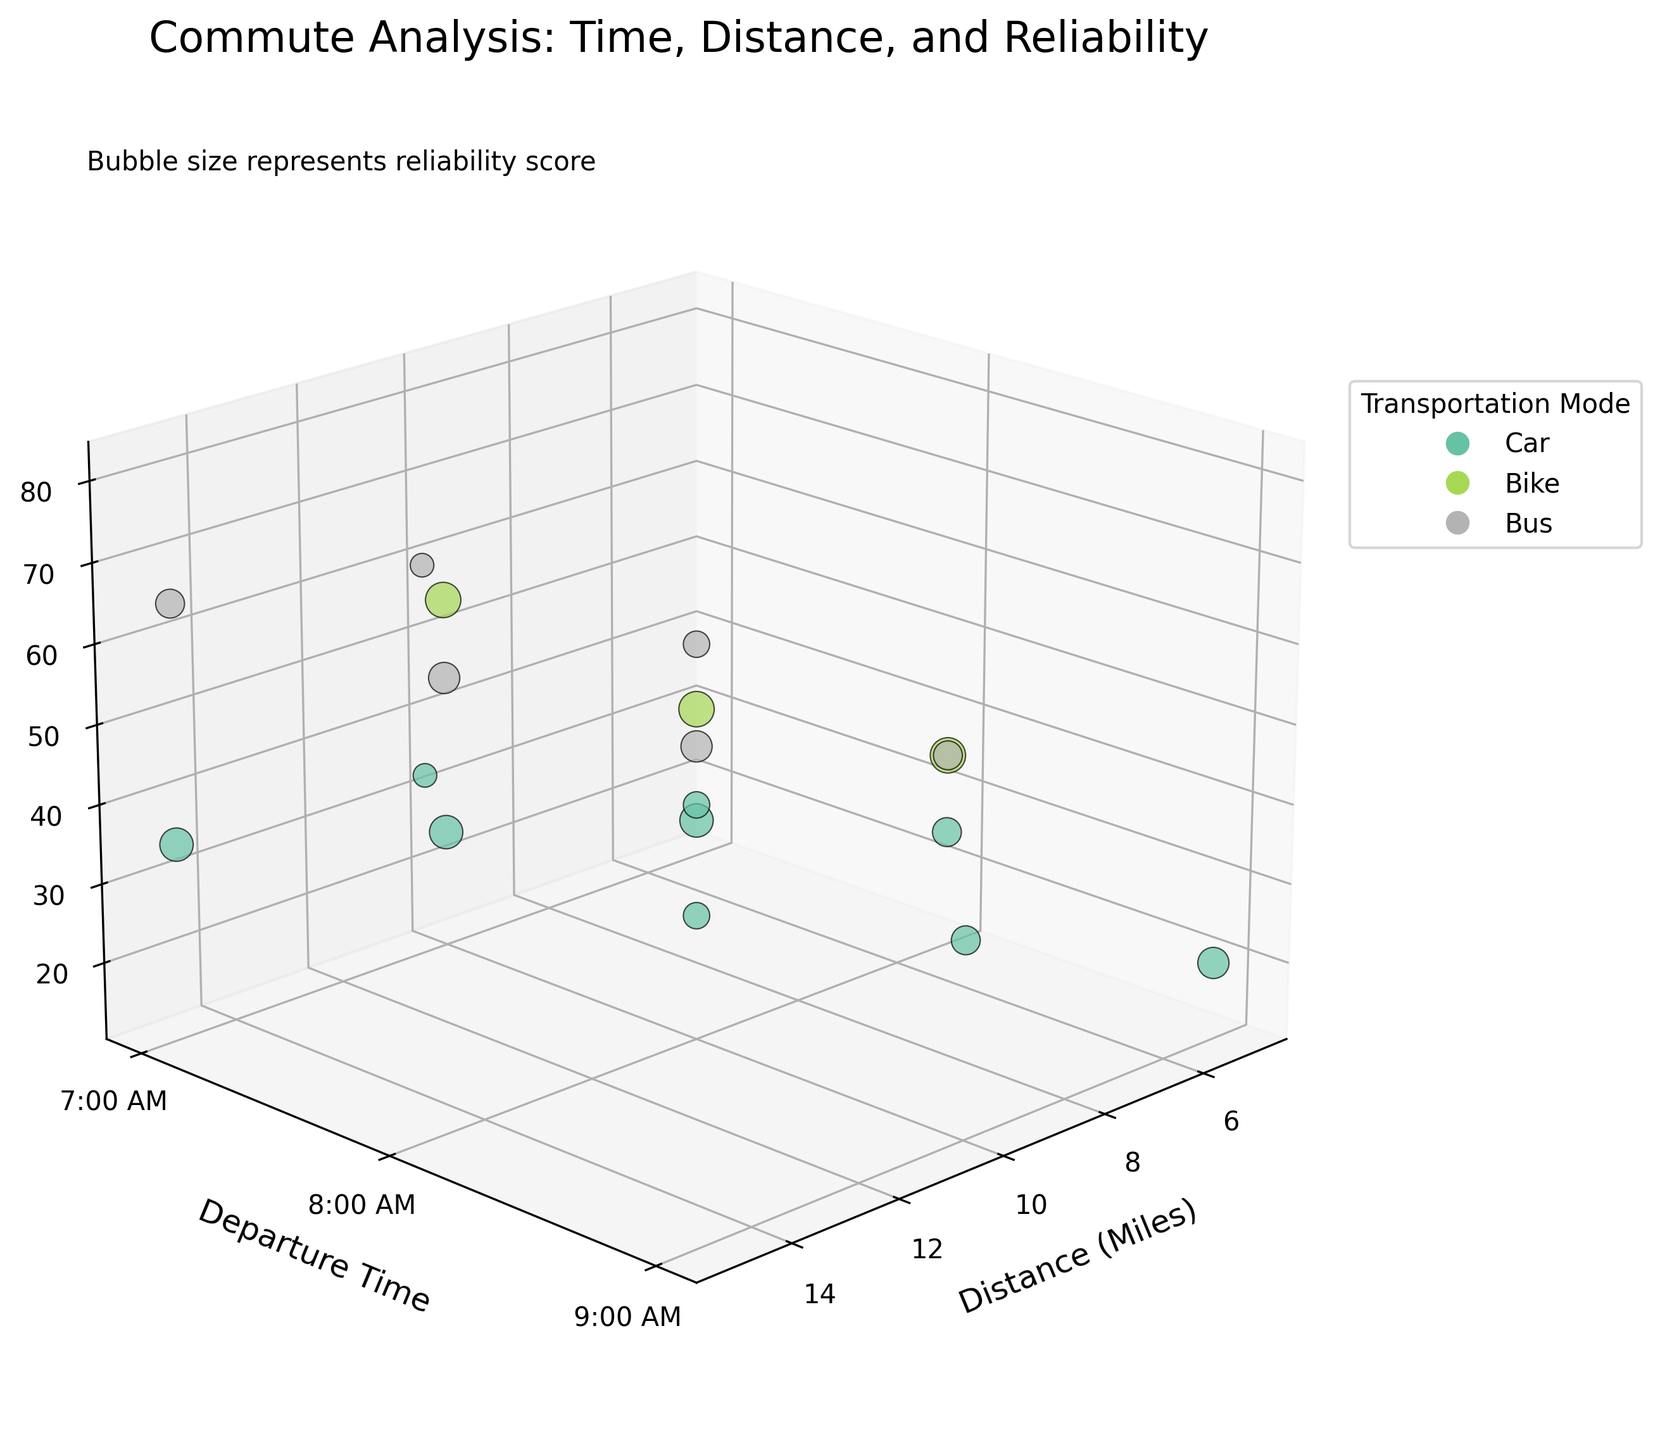How many distinct modes of transportation are represented on the chart? Count the unique colors in the plot's legend, each representing a different mode of transportation.
Answer: 3 What is the title of the figure? Read the title at the top of the chart.
Answer: Commute Analysis: Time, Distance, and Reliability How does the commute time change for car rides as the departure time moves from 7:00 AM to 8:00 AM for a 10-mile distance? Find the z-values for car rides with a 10-mile distance at 7:00 AM and 8:00 AM, then calculate the difference.
Answer: Increases from 25 to 40 minutes Which transportation mode has the highest reliability score for a 5-mile trip at 7:00 AM? Compare the bubble sizes (reliability scores) for different modes of transportation at a 5-mile distance and 7:00 AM departure time.
Answer: Bike Between the bike and bus, which one has a longer average commute time for trips of 10 miles at 7:00 AM? Find the z-values for a 10-mile trip at 7:00 AM for both bike and bus, then calculate the average for each mode and compare them.
Answer: Bike What is the significance of the bubble size in the chart? Read the text annotation provided near the chart that explains the bubble size.
Answer: Represents reliability score At what departure time does the car have the lowest commute time for a 5-mile trip? Compare the z-values for car rides at a 5-mile distance across different departure times (7:00 AM, 8:00 AM, 9:00 AM) and find the minimum.
Answer: 7:00 AM Which mode of transportation has the worst reliability score for a 15-mile trip at 8:00 AM? Compare the bubble sizes (reliability scores) of different transportation modes for a 15-mile distance at 8:00 AM.
Answer: Bus How does the commute time for a bus compare between 7:00 AM and 8:00 AM for a 5-mile trip? Compare the z-values for the bus at a 5-mile distance for 7:00 AM and 8:00 AM departure times.
Answer: Increases from 25 to 35 minutes Which transportation mode shows the largest increase in commute time between 7:00 AM and 8:00 AM for all distances considered? Evaluate the change in z-values between 7:00 AM and 8:00 AM for each mode of transportation across all distances, and identify the mode with the largest increase.
Answer: Car 